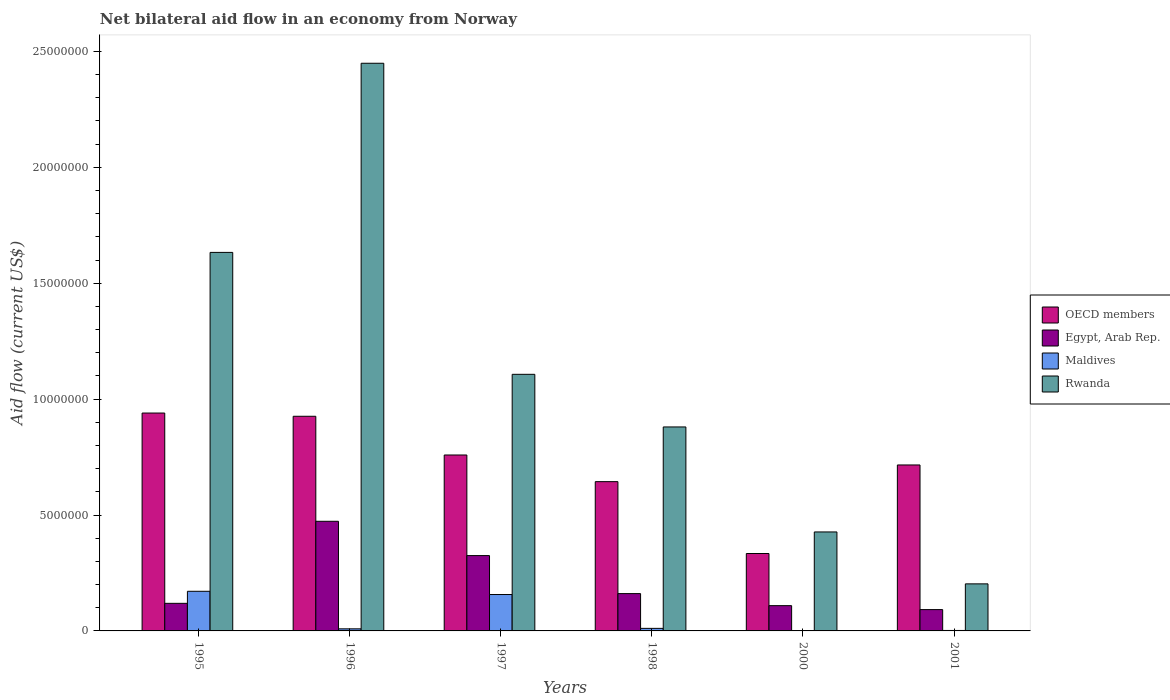How many different coloured bars are there?
Give a very brief answer. 4. Are the number of bars per tick equal to the number of legend labels?
Provide a succinct answer. Yes. Are the number of bars on each tick of the X-axis equal?
Your response must be concise. Yes. How many bars are there on the 4th tick from the left?
Make the answer very short. 4. What is the net bilateral aid flow in Rwanda in 1997?
Ensure brevity in your answer.  1.11e+07. Across all years, what is the maximum net bilateral aid flow in OECD members?
Make the answer very short. 9.40e+06. Across all years, what is the minimum net bilateral aid flow in Rwanda?
Offer a very short reply. 2.03e+06. In which year was the net bilateral aid flow in Rwanda maximum?
Ensure brevity in your answer.  1996. In which year was the net bilateral aid flow in Egypt, Arab Rep. minimum?
Ensure brevity in your answer.  2001. What is the total net bilateral aid flow in Egypt, Arab Rep. in the graph?
Keep it short and to the point. 1.28e+07. What is the difference between the net bilateral aid flow in OECD members in 1996 and that in 1997?
Ensure brevity in your answer.  1.67e+06. What is the difference between the net bilateral aid flow in Rwanda in 2000 and the net bilateral aid flow in OECD members in 1995?
Your answer should be very brief. -5.13e+06. What is the average net bilateral aid flow in Egypt, Arab Rep. per year?
Keep it short and to the point. 2.13e+06. In the year 1998, what is the difference between the net bilateral aid flow in Egypt, Arab Rep. and net bilateral aid flow in Maldives?
Offer a terse response. 1.50e+06. In how many years, is the net bilateral aid flow in Rwanda greater than 2000000 US$?
Your answer should be compact. 6. What is the ratio of the net bilateral aid flow in Rwanda in 1995 to that in 1996?
Your answer should be compact. 0.67. Is the net bilateral aid flow in Egypt, Arab Rep. in 1996 less than that in 1997?
Provide a short and direct response. No. Is the difference between the net bilateral aid flow in Egypt, Arab Rep. in 1995 and 1998 greater than the difference between the net bilateral aid flow in Maldives in 1995 and 1998?
Keep it short and to the point. No. What is the difference between the highest and the second highest net bilateral aid flow in Egypt, Arab Rep.?
Offer a terse response. 1.48e+06. What is the difference between the highest and the lowest net bilateral aid flow in OECD members?
Offer a terse response. 6.06e+06. In how many years, is the net bilateral aid flow in OECD members greater than the average net bilateral aid flow in OECD members taken over all years?
Give a very brief answer. 3. Is it the case that in every year, the sum of the net bilateral aid flow in OECD members and net bilateral aid flow in Rwanda is greater than the sum of net bilateral aid flow in Maldives and net bilateral aid flow in Egypt, Arab Rep.?
Your answer should be very brief. Yes. What does the 3rd bar from the left in 1998 represents?
Provide a succinct answer. Maldives. What does the 3rd bar from the right in 1998 represents?
Your answer should be very brief. Egypt, Arab Rep. How many bars are there?
Ensure brevity in your answer.  24. How many years are there in the graph?
Offer a very short reply. 6. What is the difference between two consecutive major ticks on the Y-axis?
Give a very brief answer. 5.00e+06. Are the values on the major ticks of Y-axis written in scientific E-notation?
Ensure brevity in your answer.  No. Does the graph contain any zero values?
Your response must be concise. No. Does the graph contain grids?
Ensure brevity in your answer.  No. Where does the legend appear in the graph?
Make the answer very short. Center right. How many legend labels are there?
Offer a terse response. 4. How are the legend labels stacked?
Your response must be concise. Vertical. What is the title of the graph?
Offer a very short reply. Net bilateral aid flow in an economy from Norway. What is the label or title of the Y-axis?
Your response must be concise. Aid flow (current US$). What is the Aid flow (current US$) in OECD members in 1995?
Offer a very short reply. 9.40e+06. What is the Aid flow (current US$) in Egypt, Arab Rep. in 1995?
Ensure brevity in your answer.  1.19e+06. What is the Aid flow (current US$) in Maldives in 1995?
Your response must be concise. 1.71e+06. What is the Aid flow (current US$) of Rwanda in 1995?
Keep it short and to the point. 1.63e+07. What is the Aid flow (current US$) in OECD members in 1996?
Your response must be concise. 9.26e+06. What is the Aid flow (current US$) in Egypt, Arab Rep. in 1996?
Offer a terse response. 4.73e+06. What is the Aid flow (current US$) of Rwanda in 1996?
Keep it short and to the point. 2.45e+07. What is the Aid flow (current US$) of OECD members in 1997?
Provide a short and direct response. 7.59e+06. What is the Aid flow (current US$) of Egypt, Arab Rep. in 1997?
Your answer should be very brief. 3.25e+06. What is the Aid flow (current US$) of Maldives in 1997?
Your answer should be very brief. 1.57e+06. What is the Aid flow (current US$) of Rwanda in 1997?
Offer a terse response. 1.11e+07. What is the Aid flow (current US$) in OECD members in 1998?
Your answer should be very brief. 6.44e+06. What is the Aid flow (current US$) of Egypt, Arab Rep. in 1998?
Offer a very short reply. 1.61e+06. What is the Aid flow (current US$) in Rwanda in 1998?
Make the answer very short. 8.80e+06. What is the Aid flow (current US$) in OECD members in 2000?
Keep it short and to the point. 3.34e+06. What is the Aid flow (current US$) of Egypt, Arab Rep. in 2000?
Provide a short and direct response. 1.09e+06. What is the Aid flow (current US$) in Rwanda in 2000?
Provide a succinct answer. 4.27e+06. What is the Aid flow (current US$) of OECD members in 2001?
Ensure brevity in your answer.  7.16e+06. What is the Aid flow (current US$) in Egypt, Arab Rep. in 2001?
Offer a very short reply. 9.20e+05. What is the Aid flow (current US$) in Maldives in 2001?
Give a very brief answer. 2.00e+04. What is the Aid flow (current US$) in Rwanda in 2001?
Provide a short and direct response. 2.03e+06. Across all years, what is the maximum Aid flow (current US$) of OECD members?
Your answer should be compact. 9.40e+06. Across all years, what is the maximum Aid flow (current US$) in Egypt, Arab Rep.?
Give a very brief answer. 4.73e+06. Across all years, what is the maximum Aid flow (current US$) of Maldives?
Your response must be concise. 1.71e+06. Across all years, what is the maximum Aid flow (current US$) of Rwanda?
Keep it short and to the point. 2.45e+07. Across all years, what is the minimum Aid flow (current US$) of OECD members?
Your answer should be very brief. 3.34e+06. Across all years, what is the minimum Aid flow (current US$) of Egypt, Arab Rep.?
Keep it short and to the point. 9.20e+05. Across all years, what is the minimum Aid flow (current US$) in Rwanda?
Your answer should be very brief. 2.03e+06. What is the total Aid flow (current US$) of OECD members in the graph?
Ensure brevity in your answer.  4.32e+07. What is the total Aid flow (current US$) of Egypt, Arab Rep. in the graph?
Offer a very short reply. 1.28e+07. What is the total Aid flow (current US$) of Maldives in the graph?
Provide a short and direct response. 3.51e+06. What is the total Aid flow (current US$) in Rwanda in the graph?
Your answer should be very brief. 6.70e+07. What is the difference between the Aid flow (current US$) in Egypt, Arab Rep. in 1995 and that in 1996?
Offer a very short reply. -3.54e+06. What is the difference between the Aid flow (current US$) in Maldives in 1995 and that in 1996?
Offer a terse response. 1.62e+06. What is the difference between the Aid flow (current US$) in Rwanda in 1995 and that in 1996?
Offer a terse response. -8.16e+06. What is the difference between the Aid flow (current US$) of OECD members in 1995 and that in 1997?
Offer a very short reply. 1.81e+06. What is the difference between the Aid flow (current US$) of Egypt, Arab Rep. in 1995 and that in 1997?
Keep it short and to the point. -2.06e+06. What is the difference between the Aid flow (current US$) of Maldives in 1995 and that in 1997?
Your answer should be compact. 1.40e+05. What is the difference between the Aid flow (current US$) of Rwanda in 1995 and that in 1997?
Offer a very short reply. 5.26e+06. What is the difference between the Aid flow (current US$) in OECD members in 1995 and that in 1998?
Your answer should be compact. 2.96e+06. What is the difference between the Aid flow (current US$) in Egypt, Arab Rep. in 1995 and that in 1998?
Ensure brevity in your answer.  -4.20e+05. What is the difference between the Aid flow (current US$) in Maldives in 1995 and that in 1998?
Provide a short and direct response. 1.60e+06. What is the difference between the Aid flow (current US$) of Rwanda in 1995 and that in 1998?
Ensure brevity in your answer.  7.53e+06. What is the difference between the Aid flow (current US$) of OECD members in 1995 and that in 2000?
Your answer should be very brief. 6.06e+06. What is the difference between the Aid flow (current US$) in Egypt, Arab Rep. in 1995 and that in 2000?
Keep it short and to the point. 1.00e+05. What is the difference between the Aid flow (current US$) of Maldives in 1995 and that in 2000?
Provide a short and direct response. 1.70e+06. What is the difference between the Aid flow (current US$) of Rwanda in 1995 and that in 2000?
Give a very brief answer. 1.21e+07. What is the difference between the Aid flow (current US$) in OECD members in 1995 and that in 2001?
Offer a terse response. 2.24e+06. What is the difference between the Aid flow (current US$) of Egypt, Arab Rep. in 1995 and that in 2001?
Provide a short and direct response. 2.70e+05. What is the difference between the Aid flow (current US$) of Maldives in 1995 and that in 2001?
Your answer should be compact. 1.69e+06. What is the difference between the Aid flow (current US$) in Rwanda in 1995 and that in 2001?
Offer a very short reply. 1.43e+07. What is the difference between the Aid flow (current US$) in OECD members in 1996 and that in 1997?
Give a very brief answer. 1.67e+06. What is the difference between the Aid flow (current US$) of Egypt, Arab Rep. in 1996 and that in 1997?
Provide a short and direct response. 1.48e+06. What is the difference between the Aid flow (current US$) in Maldives in 1996 and that in 1997?
Provide a short and direct response. -1.48e+06. What is the difference between the Aid flow (current US$) of Rwanda in 1996 and that in 1997?
Provide a short and direct response. 1.34e+07. What is the difference between the Aid flow (current US$) in OECD members in 1996 and that in 1998?
Give a very brief answer. 2.82e+06. What is the difference between the Aid flow (current US$) in Egypt, Arab Rep. in 1996 and that in 1998?
Provide a short and direct response. 3.12e+06. What is the difference between the Aid flow (current US$) of Maldives in 1996 and that in 1998?
Your response must be concise. -2.00e+04. What is the difference between the Aid flow (current US$) of Rwanda in 1996 and that in 1998?
Your answer should be compact. 1.57e+07. What is the difference between the Aid flow (current US$) of OECD members in 1996 and that in 2000?
Your response must be concise. 5.92e+06. What is the difference between the Aid flow (current US$) in Egypt, Arab Rep. in 1996 and that in 2000?
Keep it short and to the point. 3.64e+06. What is the difference between the Aid flow (current US$) in Rwanda in 1996 and that in 2000?
Your response must be concise. 2.02e+07. What is the difference between the Aid flow (current US$) in OECD members in 1996 and that in 2001?
Keep it short and to the point. 2.10e+06. What is the difference between the Aid flow (current US$) in Egypt, Arab Rep. in 1996 and that in 2001?
Ensure brevity in your answer.  3.81e+06. What is the difference between the Aid flow (current US$) in Maldives in 1996 and that in 2001?
Ensure brevity in your answer.  7.00e+04. What is the difference between the Aid flow (current US$) of Rwanda in 1996 and that in 2001?
Your answer should be very brief. 2.25e+07. What is the difference between the Aid flow (current US$) in OECD members in 1997 and that in 1998?
Your answer should be compact. 1.15e+06. What is the difference between the Aid flow (current US$) of Egypt, Arab Rep. in 1997 and that in 1998?
Offer a terse response. 1.64e+06. What is the difference between the Aid flow (current US$) in Maldives in 1997 and that in 1998?
Offer a terse response. 1.46e+06. What is the difference between the Aid flow (current US$) of Rwanda in 1997 and that in 1998?
Ensure brevity in your answer.  2.27e+06. What is the difference between the Aid flow (current US$) in OECD members in 1997 and that in 2000?
Your response must be concise. 4.25e+06. What is the difference between the Aid flow (current US$) of Egypt, Arab Rep. in 1997 and that in 2000?
Offer a terse response. 2.16e+06. What is the difference between the Aid flow (current US$) of Maldives in 1997 and that in 2000?
Provide a short and direct response. 1.56e+06. What is the difference between the Aid flow (current US$) in Rwanda in 1997 and that in 2000?
Provide a short and direct response. 6.80e+06. What is the difference between the Aid flow (current US$) of OECD members in 1997 and that in 2001?
Keep it short and to the point. 4.30e+05. What is the difference between the Aid flow (current US$) of Egypt, Arab Rep. in 1997 and that in 2001?
Offer a terse response. 2.33e+06. What is the difference between the Aid flow (current US$) of Maldives in 1997 and that in 2001?
Keep it short and to the point. 1.55e+06. What is the difference between the Aid flow (current US$) in Rwanda in 1997 and that in 2001?
Give a very brief answer. 9.04e+06. What is the difference between the Aid flow (current US$) in OECD members in 1998 and that in 2000?
Provide a succinct answer. 3.10e+06. What is the difference between the Aid flow (current US$) in Egypt, Arab Rep. in 1998 and that in 2000?
Ensure brevity in your answer.  5.20e+05. What is the difference between the Aid flow (current US$) in Maldives in 1998 and that in 2000?
Make the answer very short. 1.00e+05. What is the difference between the Aid flow (current US$) in Rwanda in 1998 and that in 2000?
Provide a succinct answer. 4.53e+06. What is the difference between the Aid flow (current US$) in OECD members in 1998 and that in 2001?
Your response must be concise. -7.20e+05. What is the difference between the Aid flow (current US$) in Egypt, Arab Rep. in 1998 and that in 2001?
Your answer should be compact. 6.90e+05. What is the difference between the Aid flow (current US$) in Rwanda in 1998 and that in 2001?
Your response must be concise. 6.77e+06. What is the difference between the Aid flow (current US$) in OECD members in 2000 and that in 2001?
Make the answer very short. -3.82e+06. What is the difference between the Aid flow (current US$) of Rwanda in 2000 and that in 2001?
Give a very brief answer. 2.24e+06. What is the difference between the Aid flow (current US$) in OECD members in 1995 and the Aid flow (current US$) in Egypt, Arab Rep. in 1996?
Keep it short and to the point. 4.67e+06. What is the difference between the Aid flow (current US$) in OECD members in 1995 and the Aid flow (current US$) in Maldives in 1996?
Ensure brevity in your answer.  9.31e+06. What is the difference between the Aid flow (current US$) of OECD members in 1995 and the Aid flow (current US$) of Rwanda in 1996?
Keep it short and to the point. -1.51e+07. What is the difference between the Aid flow (current US$) of Egypt, Arab Rep. in 1995 and the Aid flow (current US$) of Maldives in 1996?
Keep it short and to the point. 1.10e+06. What is the difference between the Aid flow (current US$) of Egypt, Arab Rep. in 1995 and the Aid flow (current US$) of Rwanda in 1996?
Your answer should be compact. -2.33e+07. What is the difference between the Aid flow (current US$) in Maldives in 1995 and the Aid flow (current US$) in Rwanda in 1996?
Keep it short and to the point. -2.28e+07. What is the difference between the Aid flow (current US$) in OECD members in 1995 and the Aid flow (current US$) in Egypt, Arab Rep. in 1997?
Give a very brief answer. 6.15e+06. What is the difference between the Aid flow (current US$) in OECD members in 1995 and the Aid flow (current US$) in Maldives in 1997?
Provide a short and direct response. 7.83e+06. What is the difference between the Aid flow (current US$) in OECD members in 1995 and the Aid flow (current US$) in Rwanda in 1997?
Keep it short and to the point. -1.67e+06. What is the difference between the Aid flow (current US$) in Egypt, Arab Rep. in 1995 and the Aid flow (current US$) in Maldives in 1997?
Ensure brevity in your answer.  -3.80e+05. What is the difference between the Aid flow (current US$) in Egypt, Arab Rep. in 1995 and the Aid flow (current US$) in Rwanda in 1997?
Give a very brief answer. -9.88e+06. What is the difference between the Aid flow (current US$) of Maldives in 1995 and the Aid flow (current US$) of Rwanda in 1997?
Your answer should be very brief. -9.36e+06. What is the difference between the Aid flow (current US$) in OECD members in 1995 and the Aid flow (current US$) in Egypt, Arab Rep. in 1998?
Ensure brevity in your answer.  7.79e+06. What is the difference between the Aid flow (current US$) in OECD members in 1995 and the Aid flow (current US$) in Maldives in 1998?
Make the answer very short. 9.29e+06. What is the difference between the Aid flow (current US$) in OECD members in 1995 and the Aid flow (current US$) in Rwanda in 1998?
Provide a succinct answer. 6.00e+05. What is the difference between the Aid flow (current US$) of Egypt, Arab Rep. in 1995 and the Aid flow (current US$) of Maldives in 1998?
Your response must be concise. 1.08e+06. What is the difference between the Aid flow (current US$) of Egypt, Arab Rep. in 1995 and the Aid flow (current US$) of Rwanda in 1998?
Offer a terse response. -7.61e+06. What is the difference between the Aid flow (current US$) of Maldives in 1995 and the Aid flow (current US$) of Rwanda in 1998?
Give a very brief answer. -7.09e+06. What is the difference between the Aid flow (current US$) of OECD members in 1995 and the Aid flow (current US$) of Egypt, Arab Rep. in 2000?
Your answer should be compact. 8.31e+06. What is the difference between the Aid flow (current US$) in OECD members in 1995 and the Aid flow (current US$) in Maldives in 2000?
Your answer should be compact. 9.39e+06. What is the difference between the Aid flow (current US$) of OECD members in 1995 and the Aid flow (current US$) of Rwanda in 2000?
Your answer should be compact. 5.13e+06. What is the difference between the Aid flow (current US$) in Egypt, Arab Rep. in 1995 and the Aid flow (current US$) in Maldives in 2000?
Your answer should be compact. 1.18e+06. What is the difference between the Aid flow (current US$) in Egypt, Arab Rep. in 1995 and the Aid flow (current US$) in Rwanda in 2000?
Offer a very short reply. -3.08e+06. What is the difference between the Aid flow (current US$) of Maldives in 1995 and the Aid flow (current US$) of Rwanda in 2000?
Make the answer very short. -2.56e+06. What is the difference between the Aid flow (current US$) in OECD members in 1995 and the Aid flow (current US$) in Egypt, Arab Rep. in 2001?
Your response must be concise. 8.48e+06. What is the difference between the Aid flow (current US$) in OECD members in 1995 and the Aid flow (current US$) in Maldives in 2001?
Your response must be concise. 9.38e+06. What is the difference between the Aid flow (current US$) in OECD members in 1995 and the Aid flow (current US$) in Rwanda in 2001?
Offer a very short reply. 7.37e+06. What is the difference between the Aid flow (current US$) of Egypt, Arab Rep. in 1995 and the Aid flow (current US$) of Maldives in 2001?
Make the answer very short. 1.17e+06. What is the difference between the Aid flow (current US$) in Egypt, Arab Rep. in 1995 and the Aid flow (current US$) in Rwanda in 2001?
Provide a succinct answer. -8.40e+05. What is the difference between the Aid flow (current US$) of Maldives in 1995 and the Aid flow (current US$) of Rwanda in 2001?
Give a very brief answer. -3.20e+05. What is the difference between the Aid flow (current US$) in OECD members in 1996 and the Aid flow (current US$) in Egypt, Arab Rep. in 1997?
Ensure brevity in your answer.  6.01e+06. What is the difference between the Aid flow (current US$) in OECD members in 1996 and the Aid flow (current US$) in Maldives in 1997?
Offer a terse response. 7.69e+06. What is the difference between the Aid flow (current US$) of OECD members in 1996 and the Aid flow (current US$) of Rwanda in 1997?
Offer a terse response. -1.81e+06. What is the difference between the Aid flow (current US$) in Egypt, Arab Rep. in 1996 and the Aid flow (current US$) in Maldives in 1997?
Offer a terse response. 3.16e+06. What is the difference between the Aid flow (current US$) in Egypt, Arab Rep. in 1996 and the Aid flow (current US$) in Rwanda in 1997?
Provide a succinct answer. -6.34e+06. What is the difference between the Aid flow (current US$) of Maldives in 1996 and the Aid flow (current US$) of Rwanda in 1997?
Offer a very short reply. -1.10e+07. What is the difference between the Aid flow (current US$) in OECD members in 1996 and the Aid flow (current US$) in Egypt, Arab Rep. in 1998?
Your response must be concise. 7.65e+06. What is the difference between the Aid flow (current US$) of OECD members in 1996 and the Aid flow (current US$) of Maldives in 1998?
Offer a terse response. 9.15e+06. What is the difference between the Aid flow (current US$) in OECD members in 1996 and the Aid flow (current US$) in Rwanda in 1998?
Give a very brief answer. 4.60e+05. What is the difference between the Aid flow (current US$) in Egypt, Arab Rep. in 1996 and the Aid flow (current US$) in Maldives in 1998?
Offer a terse response. 4.62e+06. What is the difference between the Aid flow (current US$) in Egypt, Arab Rep. in 1996 and the Aid flow (current US$) in Rwanda in 1998?
Provide a succinct answer. -4.07e+06. What is the difference between the Aid flow (current US$) in Maldives in 1996 and the Aid flow (current US$) in Rwanda in 1998?
Ensure brevity in your answer.  -8.71e+06. What is the difference between the Aid flow (current US$) of OECD members in 1996 and the Aid flow (current US$) of Egypt, Arab Rep. in 2000?
Give a very brief answer. 8.17e+06. What is the difference between the Aid flow (current US$) in OECD members in 1996 and the Aid flow (current US$) in Maldives in 2000?
Offer a very short reply. 9.25e+06. What is the difference between the Aid flow (current US$) in OECD members in 1996 and the Aid flow (current US$) in Rwanda in 2000?
Give a very brief answer. 4.99e+06. What is the difference between the Aid flow (current US$) in Egypt, Arab Rep. in 1996 and the Aid flow (current US$) in Maldives in 2000?
Give a very brief answer. 4.72e+06. What is the difference between the Aid flow (current US$) in Maldives in 1996 and the Aid flow (current US$) in Rwanda in 2000?
Keep it short and to the point. -4.18e+06. What is the difference between the Aid flow (current US$) of OECD members in 1996 and the Aid flow (current US$) of Egypt, Arab Rep. in 2001?
Ensure brevity in your answer.  8.34e+06. What is the difference between the Aid flow (current US$) of OECD members in 1996 and the Aid flow (current US$) of Maldives in 2001?
Ensure brevity in your answer.  9.24e+06. What is the difference between the Aid flow (current US$) of OECD members in 1996 and the Aid flow (current US$) of Rwanda in 2001?
Ensure brevity in your answer.  7.23e+06. What is the difference between the Aid flow (current US$) of Egypt, Arab Rep. in 1996 and the Aid flow (current US$) of Maldives in 2001?
Ensure brevity in your answer.  4.71e+06. What is the difference between the Aid flow (current US$) in Egypt, Arab Rep. in 1996 and the Aid flow (current US$) in Rwanda in 2001?
Your answer should be compact. 2.70e+06. What is the difference between the Aid flow (current US$) in Maldives in 1996 and the Aid flow (current US$) in Rwanda in 2001?
Provide a succinct answer. -1.94e+06. What is the difference between the Aid flow (current US$) in OECD members in 1997 and the Aid flow (current US$) in Egypt, Arab Rep. in 1998?
Your answer should be very brief. 5.98e+06. What is the difference between the Aid flow (current US$) of OECD members in 1997 and the Aid flow (current US$) of Maldives in 1998?
Offer a very short reply. 7.48e+06. What is the difference between the Aid flow (current US$) in OECD members in 1997 and the Aid flow (current US$) in Rwanda in 1998?
Provide a short and direct response. -1.21e+06. What is the difference between the Aid flow (current US$) of Egypt, Arab Rep. in 1997 and the Aid flow (current US$) of Maldives in 1998?
Keep it short and to the point. 3.14e+06. What is the difference between the Aid flow (current US$) in Egypt, Arab Rep. in 1997 and the Aid flow (current US$) in Rwanda in 1998?
Your answer should be very brief. -5.55e+06. What is the difference between the Aid flow (current US$) of Maldives in 1997 and the Aid flow (current US$) of Rwanda in 1998?
Your response must be concise. -7.23e+06. What is the difference between the Aid flow (current US$) in OECD members in 1997 and the Aid flow (current US$) in Egypt, Arab Rep. in 2000?
Provide a succinct answer. 6.50e+06. What is the difference between the Aid flow (current US$) of OECD members in 1997 and the Aid flow (current US$) of Maldives in 2000?
Give a very brief answer. 7.58e+06. What is the difference between the Aid flow (current US$) in OECD members in 1997 and the Aid flow (current US$) in Rwanda in 2000?
Offer a terse response. 3.32e+06. What is the difference between the Aid flow (current US$) of Egypt, Arab Rep. in 1997 and the Aid flow (current US$) of Maldives in 2000?
Your response must be concise. 3.24e+06. What is the difference between the Aid flow (current US$) in Egypt, Arab Rep. in 1997 and the Aid flow (current US$) in Rwanda in 2000?
Your answer should be very brief. -1.02e+06. What is the difference between the Aid flow (current US$) in Maldives in 1997 and the Aid flow (current US$) in Rwanda in 2000?
Your answer should be very brief. -2.70e+06. What is the difference between the Aid flow (current US$) of OECD members in 1997 and the Aid flow (current US$) of Egypt, Arab Rep. in 2001?
Your answer should be compact. 6.67e+06. What is the difference between the Aid flow (current US$) of OECD members in 1997 and the Aid flow (current US$) of Maldives in 2001?
Your response must be concise. 7.57e+06. What is the difference between the Aid flow (current US$) in OECD members in 1997 and the Aid flow (current US$) in Rwanda in 2001?
Ensure brevity in your answer.  5.56e+06. What is the difference between the Aid flow (current US$) of Egypt, Arab Rep. in 1997 and the Aid flow (current US$) of Maldives in 2001?
Keep it short and to the point. 3.23e+06. What is the difference between the Aid flow (current US$) in Egypt, Arab Rep. in 1997 and the Aid flow (current US$) in Rwanda in 2001?
Provide a short and direct response. 1.22e+06. What is the difference between the Aid flow (current US$) of Maldives in 1997 and the Aid flow (current US$) of Rwanda in 2001?
Give a very brief answer. -4.60e+05. What is the difference between the Aid flow (current US$) of OECD members in 1998 and the Aid flow (current US$) of Egypt, Arab Rep. in 2000?
Keep it short and to the point. 5.35e+06. What is the difference between the Aid flow (current US$) of OECD members in 1998 and the Aid flow (current US$) of Maldives in 2000?
Give a very brief answer. 6.43e+06. What is the difference between the Aid flow (current US$) in OECD members in 1998 and the Aid flow (current US$) in Rwanda in 2000?
Offer a terse response. 2.17e+06. What is the difference between the Aid flow (current US$) in Egypt, Arab Rep. in 1998 and the Aid flow (current US$) in Maldives in 2000?
Your answer should be very brief. 1.60e+06. What is the difference between the Aid flow (current US$) of Egypt, Arab Rep. in 1998 and the Aid flow (current US$) of Rwanda in 2000?
Provide a short and direct response. -2.66e+06. What is the difference between the Aid flow (current US$) of Maldives in 1998 and the Aid flow (current US$) of Rwanda in 2000?
Make the answer very short. -4.16e+06. What is the difference between the Aid flow (current US$) in OECD members in 1998 and the Aid flow (current US$) in Egypt, Arab Rep. in 2001?
Provide a short and direct response. 5.52e+06. What is the difference between the Aid flow (current US$) in OECD members in 1998 and the Aid flow (current US$) in Maldives in 2001?
Give a very brief answer. 6.42e+06. What is the difference between the Aid flow (current US$) of OECD members in 1998 and the Aid flow (current US$) of Rwanda in 2001?
Provide a succinct answer. 4.41e+06. What is the difference between the Aid flow (current US$) in Egypt, Arab Rep. in 1998 and the Aid flow (current US$) in Maldives in 2001?
Your answer should be compact. 1.59e+06. What is the difference between the Aid flow (current US$) in Egypt, Arab Rep. in 1998 and the Aid flow (current US$) in Rwanda in 2001?
Your answer should be very brief. -4.20e+05. What is the difference between the Aid flow (current US$) in Maldives in 1998 and the Aid flow (current US$) in Rwanda in 2001?
Your answer should be very brief. -1.92e+06. What is the difference between the Aid flow (current US$) of OECD members in 2000 and the Aid flow (current US$) of Egypt, Arab Rep. in 2001?
Provide a succinct answer. 2.42e+06. What is the difference between the Aid flow (current US$) of OECD members in 2000 and the Aid flow (current US$) of Maldives in 2001?
Offer a terse response. 3.32e+06. What is the difference between the Aid flow (current US$) in OECD members in 2000 and the Aid flow (current US$) in Rwanda in 2001?
Provide a short and direct response. 1.31e+06. What is the difference between the Aid flow (current US$) of Egypt, Arab Rep. in 2000 and the Aid flow (current US$) of Maldives in 2001?
Offer a very short reply. 1.07e+06. What is the difference between the Aid flow (current US$) of Egypt, Arab Rep. in 2000 and the Aid flow (current US$) of Rwanda in 2001?
Ensure brevity in your answer.  -9.40e+05. What is the difference between the Aid flow (current US$) in Maldives in 2000 and the Aid flow (current US$) in Rwanda in 2001?
Offer a terse response. -2.02e+06. What is the average Aid flow (current US$) of OECD members per year?
Offer a very short reply. 7.20e+06. What is the average Aid flow (current US$) in Egypt, Arab Rep. per year?
Offer a terse response. 2.13e+06. What is the average Aid flow (current US$) in Maldives per year?
Provide a succinct answer. 5.85e+05. What is the average Aid flow (current US$) in Rwanda per year?
Offer a terse response. 1.12e+07. In the year 1995, what is the difference between the Aid flow (current US$) of OECD members and Aid flow (current US$) of Egypt, Arab Rep.?
Keep it short and to the point. 8.21e+06. In the year 1995, what is the difference between the Aid flow (current US$) of OECD members and Aid flow (current US$) of Maldives?
Offer a very short reply. 7.69e+06. In the year 1995, what is the difference between the Aid flow (current US$) of OECD members and Aid flow (current US$) of Rwanda?
Provide a succinct answer. -6.93e+06. In the year 1995, what is the difference between the Aid flow (current US$) in Egypt, Arab Rep. and Aid flow (current US$) in Maldives?
Your answer should be compact. -5.20e+05. In the year 1995, what is the difference between the Aid flow (current US$) of Egypt, Arab Rep. and Aid flow (current US$) of Rwanda?
Offer a very short reply. -1.51e+07. In the year 1995, what is the difference between the Aid flow (current US$) in Maldives and Aid flow (current US$) in Rwanda?
Your answer should be very brief. -1.46e+07. In the year 1996, what is the difference between the Aid flow (current US$) of OECD members and Aid flow (current US$) of Egypt, Arab Rep.?
Your answer should be compact. 4.53e+06. In the year 1996, what is the difference between the Aid flow (current US$) of OECD members and Aid flow (current US$) of Maldives?
Your response must be concise. 9.17e+06. In the year 1996, what is the difference between the Aid flow (current US$) in OECD members and Aid flow (current US$) in Rwanda?
Make the answer very short. -1.52e+07. In the year 1996, what is the difference between the Aid flow (current US$) of Egypt, Arab Rep. and Aid flow (current US$) of Maldives?
Offer a terse response. 4.64e+06. In the year 1996, what is the difference between the Aid flow (current US$) in Egypt, Arab Rep. and Aid flow (current US$) in Rwanda?
Offer a terse response. -1.98e+07. In the year 1996, what is the difference between the Aid flow (current US$) in Maldives and Aid flow (current US$) in Rwanda?
Your answer should be compact. -2.44e+07. In the year 1997, what is the difference between the Aid flow (current US$) in OECD members and Aid flow (current US$) in Egypt, Arab Rep.?
Your answer should be very brief. 4.34e+06. In the year 1997, what is the difference between the Aid flow (current US$) in OECD members and Aid flow (current US$) in Maldives?
Offer a terse response. 6.02e+06. In the year 1997, what is the difference between the Aid flow (current US$) in OECD members and Aid flow (current US$) in Rwanda?
Provide a short and direct response. -3.48e+06. In the year 1997, what is the difference between the Aid flow (current US$) in Egypt, Arab Rep. and Aid flow (current US$) in Maldives?
Provide a short and direct response. 1.68e+06. In the year 1997, what is the difference between the Aid flow (current US$) in Egypt, Arab Rep. and Aid flow (current US$) in Rwanda?
Ensure brevity in your answer.  -7.82e+06. In the year 1997, what is the difference between the Aid flow (current US$) in Maldives and Aid flow (current US$) in Rwanda?
Your answer should be compact. -9.50e+06. In the year 1998, what is the difference between the Aid flow (current US$) in OECD members and Aid flow (current US$) in Egypt, Arab Rep.?
Ensure brevity in your answer.  4.83e+06. In the year 1998, what is the difference between the Aid flow (current US$) in OECD members and Aid flow (current US$) in Maldives?
Your answer should be very brief. 6.33e+06. In the year 1998, what is the difference between the Aid flow (current US$) of OECD members and Aid flow (current US$) of Rwanda?
Provide a succinct answer. -2.36e+06. In the year 1998, what is the difference between the Aid flow (current US$) of Egypt, Arab Rep. and Aid flow (current US$) of Maldives?
Your answer should be compact. 1.50e+06. In the year 1998, what is the difference between the Aid flow (current US$) of Egypt, Arab Rep. and Aid flow (current US$) of Rwanda?
Offer a terse response. -7.19e+06. In the year 1998, what is the difference between the Aid flow (current US$) of Maldives and Aid flow (current US$) of Rwanda?
Give a very brief answer. -8.69e+06. In the year 2000, what is the difference between the Aid flow (current US$) in OECD members and Aid flow (current US$) in Egypt, Arab Rep.?
Keep it short and to the point. 2.25e+06. In the year 2000, what is the difference between the Aid flow (current US$) in OECD members and Aid flow (current US$) in Maldives?
Provide a short and direct response. 3.33e+06. In the year 2000, what is the difference between the Aid flow (current US$) of OECD members and Aid flow (current US$) of Rwanda?
Make the answer very short. -9.30e+05. In the year 2000, what is the difference between the Aid flow (current US$) of Egypt, Arab Rep. and Aid flow (current US$) of Maldives?
Your response must be concise. 1.08e+06. In the year 2000, what is the difference between the Aid flow (current US$) of Egypt, Arab Rep. and Aid flow (current US$) of Rwanda?
Ensure brevity in your answer.  -3.18e+06. In the year 2000, what is the difference between the Aid flow (current US$) of Maldives and Aid flow (current US$) of Rwanda?
Your answer should be compact. -4.26e+06. In the year 2001, what is the difference between the Aid flow (current US$) of OECD members and Aid flow (current US$) of Egypt, Arab Rep.?
Ensure brevity in your answer.  6.24e+06. In the year 2001, what is the difference between the Aid flow (current US$) of OECD members and Aid flow (current US$) of Maldives?
Offer a very short reply. 7.14e+06. In the year 2001, what is the difference between the Aid flow (current US$) of OECD members and Aid flow (current US$) of Rwanda?
Your answer should be very brief. 5.13e+06. In the year 2001, what is the difference between the Aid flow (current US$) in Egypt, Arab Rep. and Aid flow (current US$) in Maldives?
Make the answer very short. 9.00e+05. In the year 2001, what is the difference between the Aid flow (current US$) of Egypt, Arab Rep. and Aid flow (current US$) of Rwanda?
Make the answer very short. -1.11e+06. In the year 2001, what is the difference between the Aid flow (current US$) of Maldives and Aid flow (current US$) of Rwanda?
Offer a very short reply. -2.01e+06. What is the ratio of the Aid flow (current US$) of OECD members in 1995 to that in 1996?
Give a very brief answer. 1.02. What is the ratio of the Aid flow (current US$) in Egypt, Arab Rep. in 1995 to that in 1996?
Give a very brief answer. 0.25. What is the ratio of the Aid flow (current US$) in Rwanda in 1995 to that in 1996?
Ensure brevity in your answer.  0.67. What is the ratio of the Aid flow (current US$) of OECD members in 1995 to that in 1997?
Make the answer very short. 1.24. What is the ratio of the Aid flow (current US$) of Egypt, Arab Rep. in 1995 to that in 1997?
Provide a short and direct response. 0.37. What is the ratio of the Aid flow (current US$) in Maldives in 1995 to that in 1997?
Offer a very short reply. 1.09. What is the ratio of the Aid flow (current US$) of Rwanda in 1995 to that in 1997?
Give a very brief answer. 1.48. What is the ratio of the Aid flow (current US$) of OECD members in 1995 to that in 1998?
Your response must be concise. 1.46. What is the ratio of the Aid flow (current US$) in Egypt, Arab Rep. in 1995 to that in 1998?
Your response must be concise. 0.74. What is the ratio of the Aid flow (current US$) in Maldives in 1995 to that in 1998?
Make the answer very short. 15.55. What is the ratio of the Aid flow (current US$) of Rwanda in 1995 to that in 1998?
Offer a terse response. 1.86. What is the ratio of the Aid flow (current US$) in OECD members in 1995 to that in 2000?
Provide a succinct answer. 2.81. What is the ratio of the Aid flow (current US$) of Egypt, Arab Rep. in 1995 to that in 2000?
Provide a short and direct response. 1.09. What is the ratio of the Aid flow (current US$) of Maldives in 1995 to that in 2000?
Keep it short and to the point. 171. What is the ratio of the Aid flow (current US$) of Rwanda in 1995 to that in 2000?
Your answer should be compact. 3.82. What is the ratio of the Aid flow (current US$) of OECD members in 1995 to that in 2001?
Your answer should be compact. 1.31. What is the ratio of the Aid flow (current US$) in Egypt, Arab Rep. in 1995 to that in 2001?
Provide a short and direct response. 1.29. What is the ratio of the Aid flow (current US$) of Maldives in 1995 to that in 2001?
Give a very brief answer. 85.5. What is the ratio of the Aid flow (current US$) of Rwanda in 1995 to that in 2001?
Ensure brevity in your answer.  8.04. What is the ratio of the Aid flow (current US$) of OECD members in 1996 to that in 1997?
Provide a succinct answer. 1.22. What is the ratio of the Aid flow (current US$) in Egypt, Arab Rep. in 1996 to that in 1997?
Ensure brevity in your answer.  1.46. What is the ratio of the Aid flow (current US$) in Maldives in 1996 to that in 1997?
Give a very brief answer. 0.06. What is the ratio of the Aid flow (current US$) in Rwanda in 1996 to that in 1997?
Provide a short and direct response. 2.21. What is the ratio of the Aid flow (current US$) in OECD members in 1996 to that in 1998?
Ensure brevity in your answer.  1.44. What is the ratio of the Aid flow (current US$) of Egypt, Arab Rep. in 1996 to that in 1998?
Ensure brevity in your answer.  2.94. What is the ratio of the Aid flow (current US$) in Maldives in 1996 to that in 1998?
Offer a very short reply. 0.82. What is the ratio of the Aid flow (current US$) of Rwanda in 1996 to that in 1998?
Your answer should be very brief. 2.78. What is the ratio of the Aid flow (current US$) of OECD members in 1996 to that in 2000?
Your answer should be compact. 2.77. What is the ratio of the Aid flow (current US$) in Egypt, Arab Rep. in 1996 to that in 2000?
Provide a succinct answer. 4.34. What is the ratio of the Aid flow (current US$) in Rwanda in 1996 to that in 2000?
Ensure brevity in your answer.  5.74. What is the ratio of the Aid flow (current US$) of OECD members in 1996 to that in 2001?
Offer a very short reply. 1.29. What is the ratio of the Aid flow (current US$) of Egypt, Arab Rep. in 1996 to that in 2001?
Keep it short and to the point. 5.14. What is the ratio of the Aid flow (current US$) of Rwanda in 1996 to that in 2001?
Make the answer very short. 12.06. What is the ratio of the Aid flow (current US$) of OECD members in 1997 to that in 1998?
Your answer should be very brief. 1.18. What is the ratio of the Aid flow (current US$) in Egypt, Arab Rep. in 1997 to that in 1998?
Offer a very short reply. 2.02. What is the ratio of the Aid flow (current US$) in Maldives in 1997 to that in 1998?
Provide a short and direct response. 14.27. What is the ratio of the Aid flow (current US$) of Rwanda in 1997 to that in 1998?
Provide a succinct answer. 1.26. What is the ratio of the Aid flow (current US$) of OECD members in 1997 to that in 2000?
Ensure brevity in your answer.  2.27. What is the ratio of the Aid flow (current US$) in Egypt, Arab Rep. in 1997 to that in 2000?
Your answer should be compact. 2.98. What is the ratio of the Aid flow (current US$) in Maldives in 1997 to that in 2000?
Provide a short and direct response. 157. What is the ratio of the Aid flow (current US$) in Rwanda in 1997 to that in 2000?
Make the answer very short. 2.59. What is the ratio of the Aid flow (current US$) in OECD members in 1997 to that in 2001?
Offer a terse response. 1.06. What is the ratio of the Aid flow (current US$) in Egypt, Arab Rep. in 1997 to that in 2001?
Your response must be concise. 3.53. What is the ratio of the Aid flow (current US$) in Maldives in 1997 to that in 2001?
Your answer should be very brief. 78.5. What is the ratio of the Aid flow (current US$) of Rwanda in 1997 to that in 2001?
Ensure brevity in your answer.  5.45. What is the ratio of the Aid flow (current US$) in OECD members in 1998 to that in 2000?
Your response must be concise. 1.93. What is the ratio of the Aid flow (current US$) of Egypt, Arab Rep. in 1998 to that in 2000?
Your response must be concise. 1.48. What is the ratio of the Aid flow (current US$) in Rwanda in 1998 to that in 2000?
Provide a short and direct response. 2.06. What is the ratio of the Aid flow (current US$) of OECD members in 1998 to that in 2001?
Provide a short and direct response. 0.9. What is the ratio of the Aid flow (current US$) of Maldives in 1998 to that in 2001?
Your answer should be compact. 5.5. What is the ratio of the Aid flow (current US$) in Rwanda in 1998 to that in 2001?
Make the answer very short. 4.33. What is the ratio of the Aid flow (current US$) of OECD members in 2000 to that in 2001?
Keep it short and to the point. 0.47. What is the ratio of the Aid flow (current US$) in Egypt, Arab Rep. in 2000 to that in 2001?
Your answer should be very brief. 1.18. What is the ratio of the Aid flow (current US$) in Rwanda in 2000 to that in 2001?
Your answer should be very brief. 2.1. What is the difference between the highest and the second highest Aid flow (current US$) of OECD members?
Your response must be concise. 1.40e+05. What is the difference between the highest and the second highest Aid flow (current US$) in Egypt, Arab Rep.?
Provide a succinct answer. 1.48e+06. What is the difference between the highest and the second highest Aid flow (current US$) in Maldives?
Offer a very short reply. 1.40e+05. What is the difference between the highest and the second highest Aid flow (current US$) of Rwanda?
Your answer should be compact. 8.16e+06. What is the difference between the highest and the lowest Aid flow (current US$) of OECD members?
Your answer should be very brief. 6.06e+06. What is the difference between the highest and the lowest Aid flow (current US$) of Egypt, Arab Rep.?
Ensure brevity in your answer.  3.81e+06. What is the difference between the highest and the lowest Aid flow (current US$) in Maldives?
Provide a short and direct response. 1.70e+06. What is the difference between the highest and the lowest Aid flow (current US$) in Rwanda?
Keep it short and to the point. 2.25e+07. 